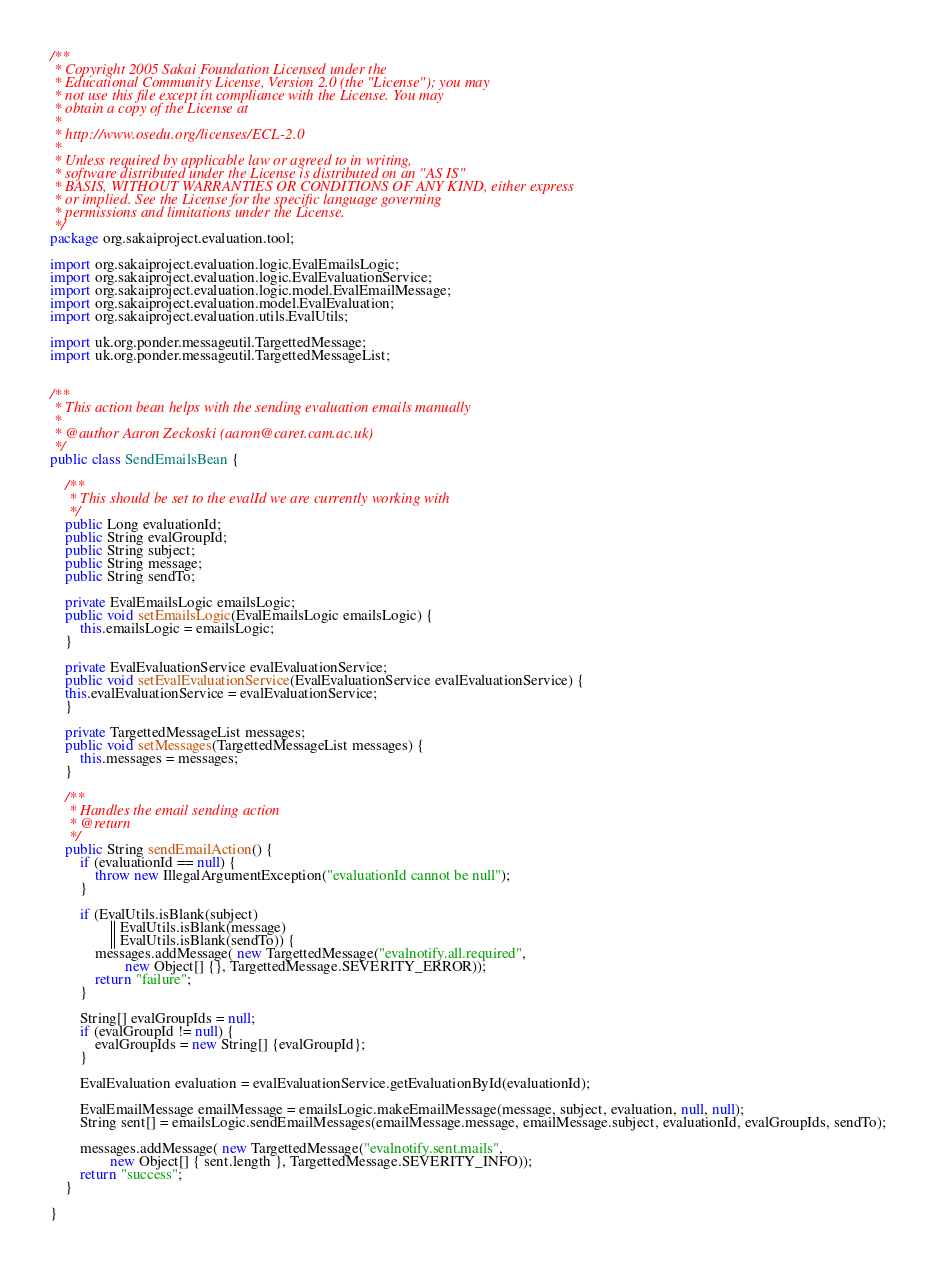Convert code to text. <code><loc_0><loc_0><loc_500><loc_500><_Java_>/**
 * Copyright 2005 Sakai Foundation Licensed under the
 * Educational Community License, Version 2.0 (the "License"); you may
 * not use this file except in compliance with the License. You may
 * obtain a copy of the License at
 *
 * http://www.osedu.org/licenses/ECL-2.0
 *
 * Unless required by applicable law or agreed to in writing,
 * software distributed under the License is distributed on an "AS IS"
 * BASIS, WITHOUT WARRANTIES OR CONDITIONS OF ANY KIND, either express
 * or implied. See the License for the specific language governing
 * permissions and limitations under the License.
 */
package org.sakaiproject.evaluation.tool;

import org.sakaiproject.evaluation.logic.EvalEmailsLogic;
import org.sakaiproject.evaluation.logic.EvalEvaluationService;
import org.sakaiproject.evaluation.logic.model.EvalEmailMessage;
import org.sakaiproject.evaluation.model.EvalEvaluation;
import org.sakaiproject.evaluation.utils.EvalUtils;

import uk.org.ponder.messageutil.TargettedMessage;
import uk.org.ponder.messageutil.TargettedMessageList;


/**
 * This action bean helps with the sending evaluation emails manually
 * 
 * @author Aaron Zeckoski (aaron@caret.cam.ac.uk)
 */
public class SendEmailsBean {

    /**
     * This should be set to the evalId we are currently working with
     */
    public Long evaluationId;
    public String evalGroupId;
    public String subject;
    public String message;
    public String sendTo;

    private EvalEmailsLogic emailsLogic;
    public void setEmailsLogic(EvalEmailsLogic emailsLogic) {
        this.emailsLogic = emailsLogic;
    }
    
    private EvalEvaluationService evalEvaluationService;
    public void setEvalEvaluationService(EvalEvaluationService evalEvaluationService) {
    this.evalEvaluationService = evalEvaluationService;
    }

    private TargettedMessageList messages;
    public void setMessages(TargettedMessageList messages) {
        this.messages = messages;
    }

    /**
     * Handles the email sending action
     * @return 
     */
    public String sendEmailAction() {
        if (evaluationId == null) {
            throw new IllegalArgumentException("evaluationId cannot be null");
        }

        if (EvalUtils.isBlank(subject)
                || EvalUtils.isBlank(message)
                || EvalUtils.isBlank(sendTo)) {
            messages.addMessage( new TargettedMessage("evalnotify.all.required",
                    new Object[] {}, TargettedMessage.SEVERITY_ERROR));
            return "failure";
        }

        String[] evalGroupIds = null;
        if (evalGroupId != null) {
            evalGroupIds = new String[] {evalGroupId};
        }

        EvalEvaluation evaluation = evalEvaluationService.getEvaluationById(evaluationId);
        
        EvalEmailMessage emailMessage = emailsLogic.makeEmailMessage(message, subject, evaluation, null, null);
        String sent[] = emailsLogic.sendEmailMessages(emailMessage.message, emailMessage.subject, evaluationId, evalGroupIds, sendTo);

        messages.addMessage( new TargettedMessage("evalnotify.sent.mails",
                new Object[] { sent.length }, TargettedMessage.SEVERITY_INFO));
        return "success";
    }

}
</code> 